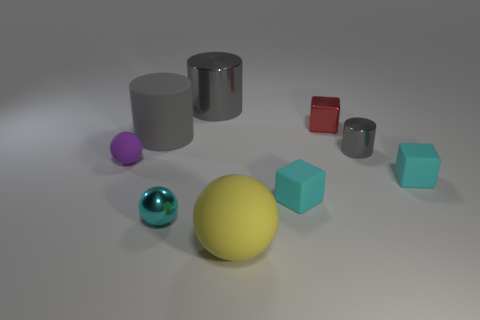Subtract all small cylinders. How many cylinders are left? 2 Subtract all red cubes. How many cubes are left? 2 Subtract all blocks. How many objects are left? 6 Subtract 2 spheres. How many spheres are left? 1 Subtract all blue cylinders. Subtract all yellow blocks. How many cylinders are left? 3 Subtract all cyan blocks. How many purple balls are left? 1 Subtract all big yellow shiny things. Subtract all big matte things. How many objects are left? 7 Add 6 tiny metal objects. How many tiny metal objects are left? 9 Add 3 green things. How many green things exist? 3 Subtract 0 green cubes. How many objects are left? 9 